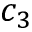Convert formula to latex. <formula><loc_0><loc_0><loc_500><loc_500>c _ { 3 }</formula> 